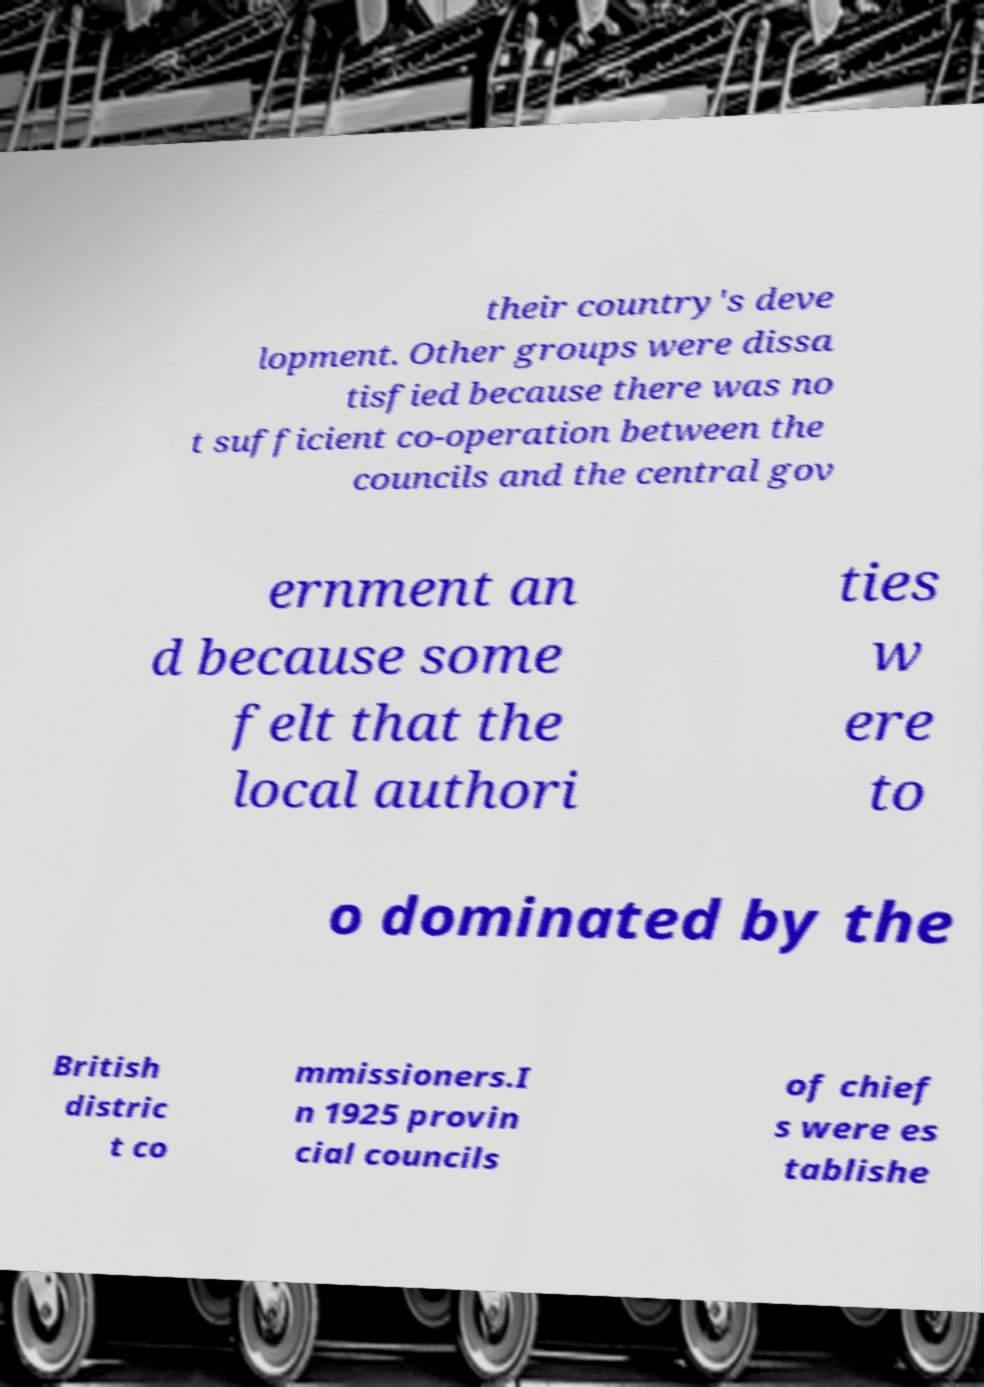I need the written content from this picture converted into text. Can you do that? their country's deve lopment. Other groups were dissa tisfied because there was no t sufficient co-operation between the councils and the central gov ernment an d because some felt that the local authori ties w ere to o dominated by the British distric t co mmissioners.I n 1925 provin cial councils of chief s were es tablishe 